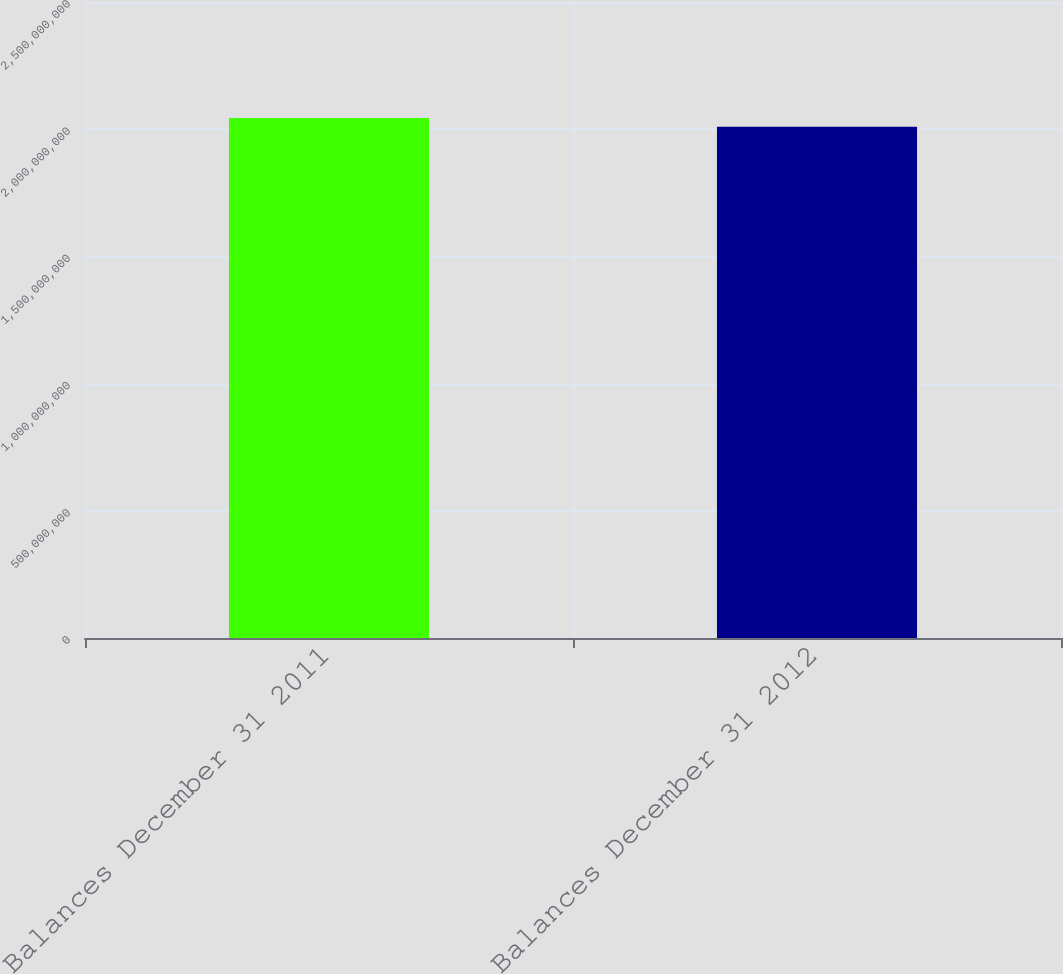Convert chart. <chart><loc_0><loc_0><loc_500><loc_500><bar_chart><fcel>Balances December 31 2011<fcel>Balances December 31 2012<nl><fcel>2.04442e+09<fcel>2.00974e+09<nl></chart> 